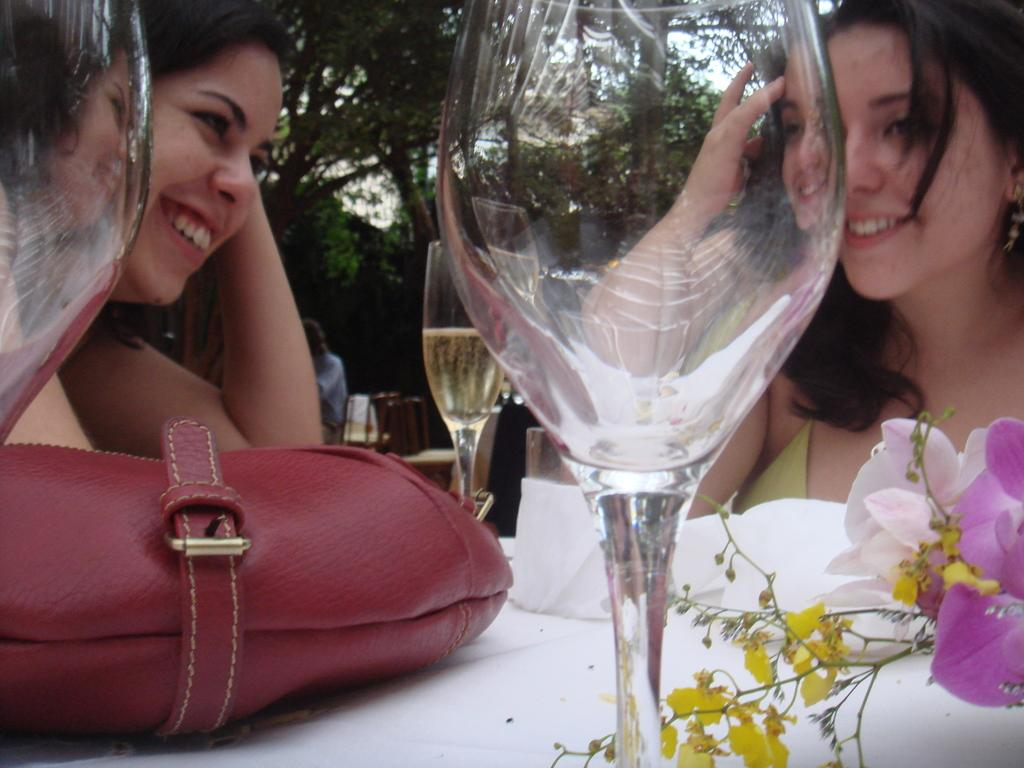How many people are in the image? There are two women in the image. What are the women doing in the image? The women are sitting on a table. What can be seen on the table besides the women? There is a red bag on the table. What is the facial expression of the women in the image? Both women are smiling. What type of insurance policy is being discussed by the women in the image? There is no indication in the image that the women are discussing insurance policies. --- Facts: 1. There is a car in the image. 2. The car is parked on the street. 3. There are trees on both sides of the street. 4. The sky is visible in the image. Absurd Topics: dance, piano, ocean Conversation: What is the main subject of the image? The main subject of the image is a car. Where is the car located in the image? The car is parked on the street. What can be seen on both sides of the street? There are trees on both sides of the street. What is visible in the background of the image? The sky is visible in the image. Reasoning: Let's think step by step in order to produce the conversation. We start by identifying the main subject of the image, which is the car. Then, we describe the car's location, noting that it is parked on the street. Next, we mention the presence of trees on both sides of the street as an additional detail. Finally, we observe the background of the image, which is the sky. Absurd Question/Answer: Can you hear the sound of the ocean in the image? There is no indication of the ocean or any sounds in the image. 